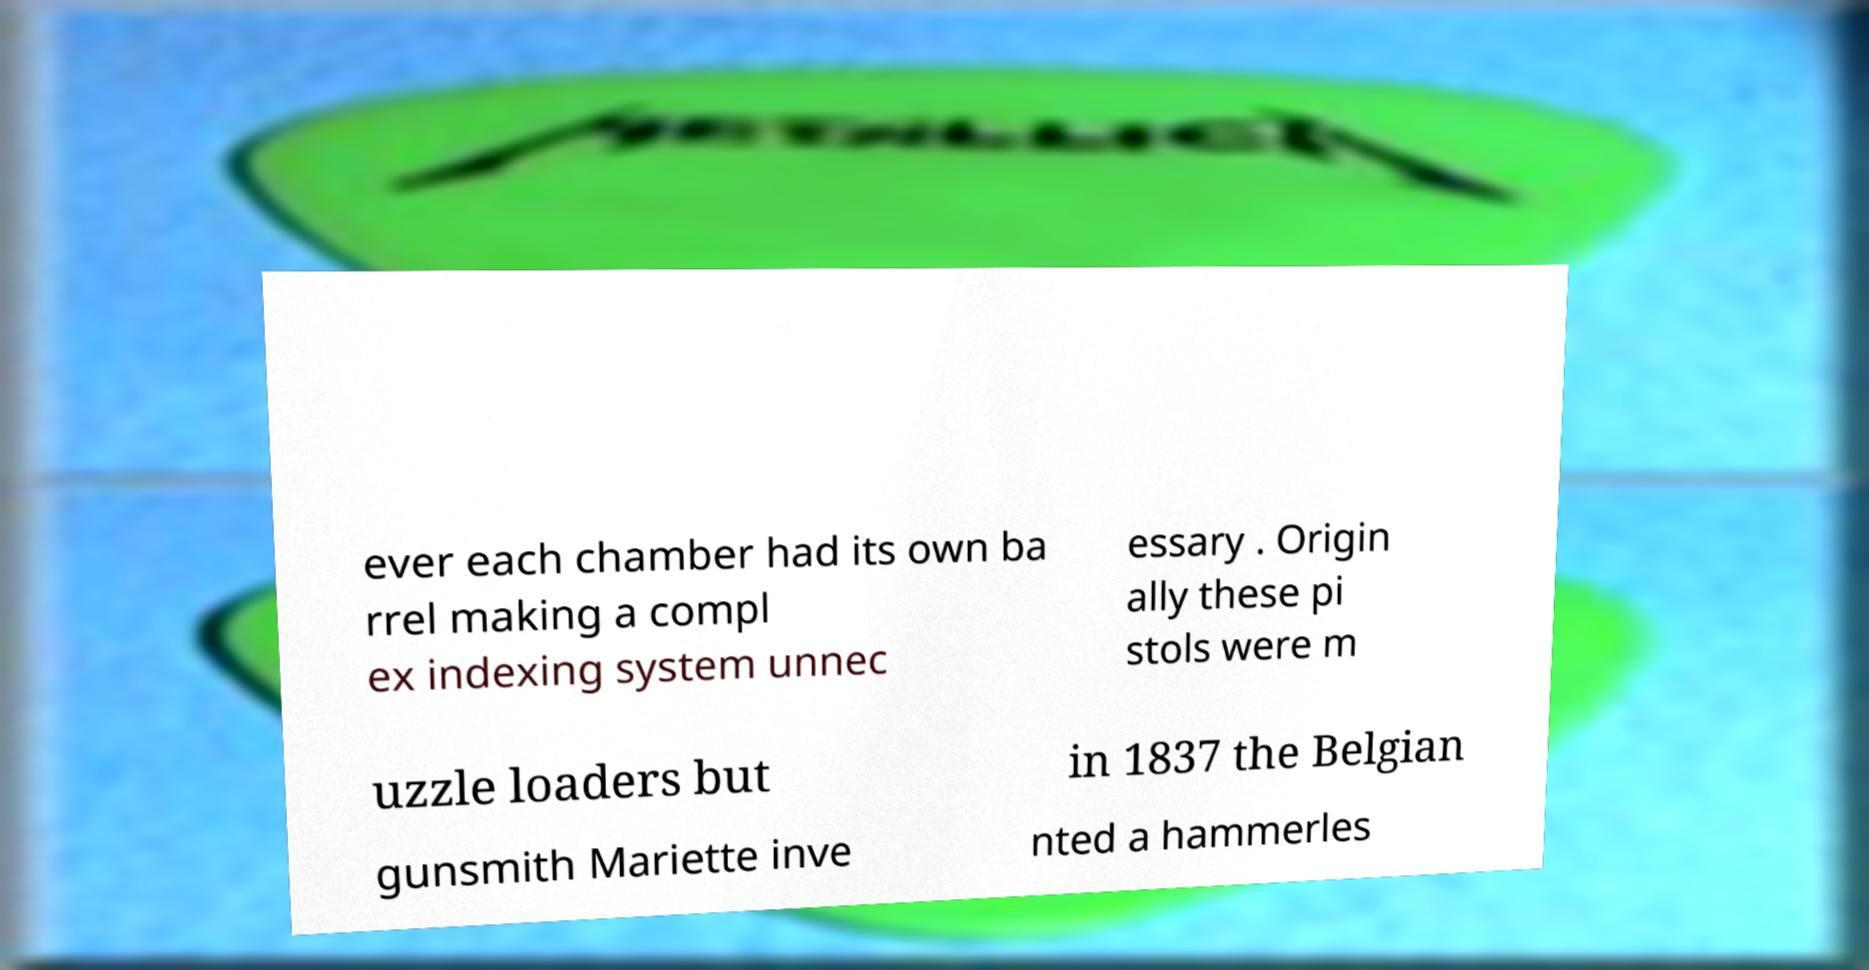Could you assist in decoding the text presented in this image and type it out clearly? ever each chamber had its own ba rrel making a compl ex indexing system unnec essary . Origin ally these pi stols were m uzzle loaders but in 1837 the Belgian gunsmith Mariette inve nted a hammerles 